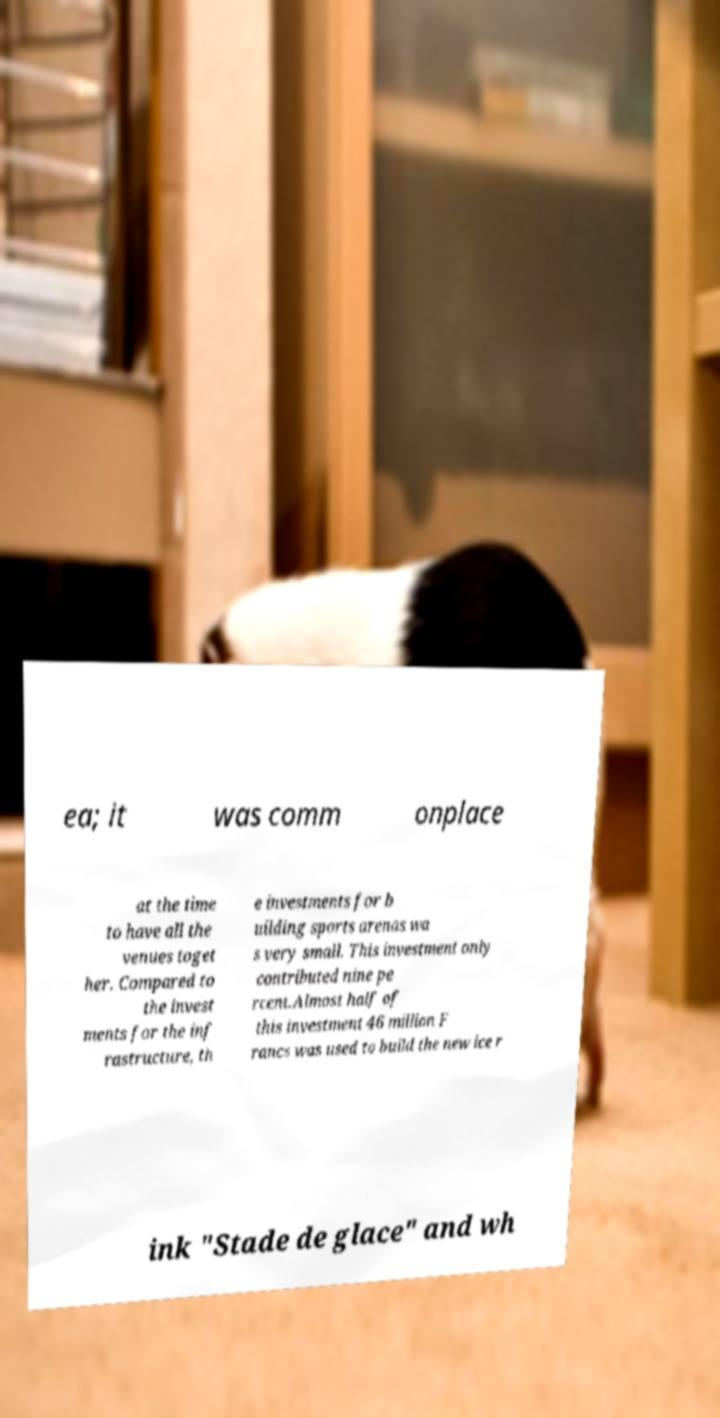Please read and relay the text visible in this image. What does it say? ea; it was comm onplace at the time to have all the venues toget her. Compared to the invest ments for the inf rastructure, th e investments for b uilding sports arenas wa s very small. This investment only contributed nine pe rcent.Almost half of this investment 46 million F rancs was used to build the new ice r ink "Stade de glace" and wh 